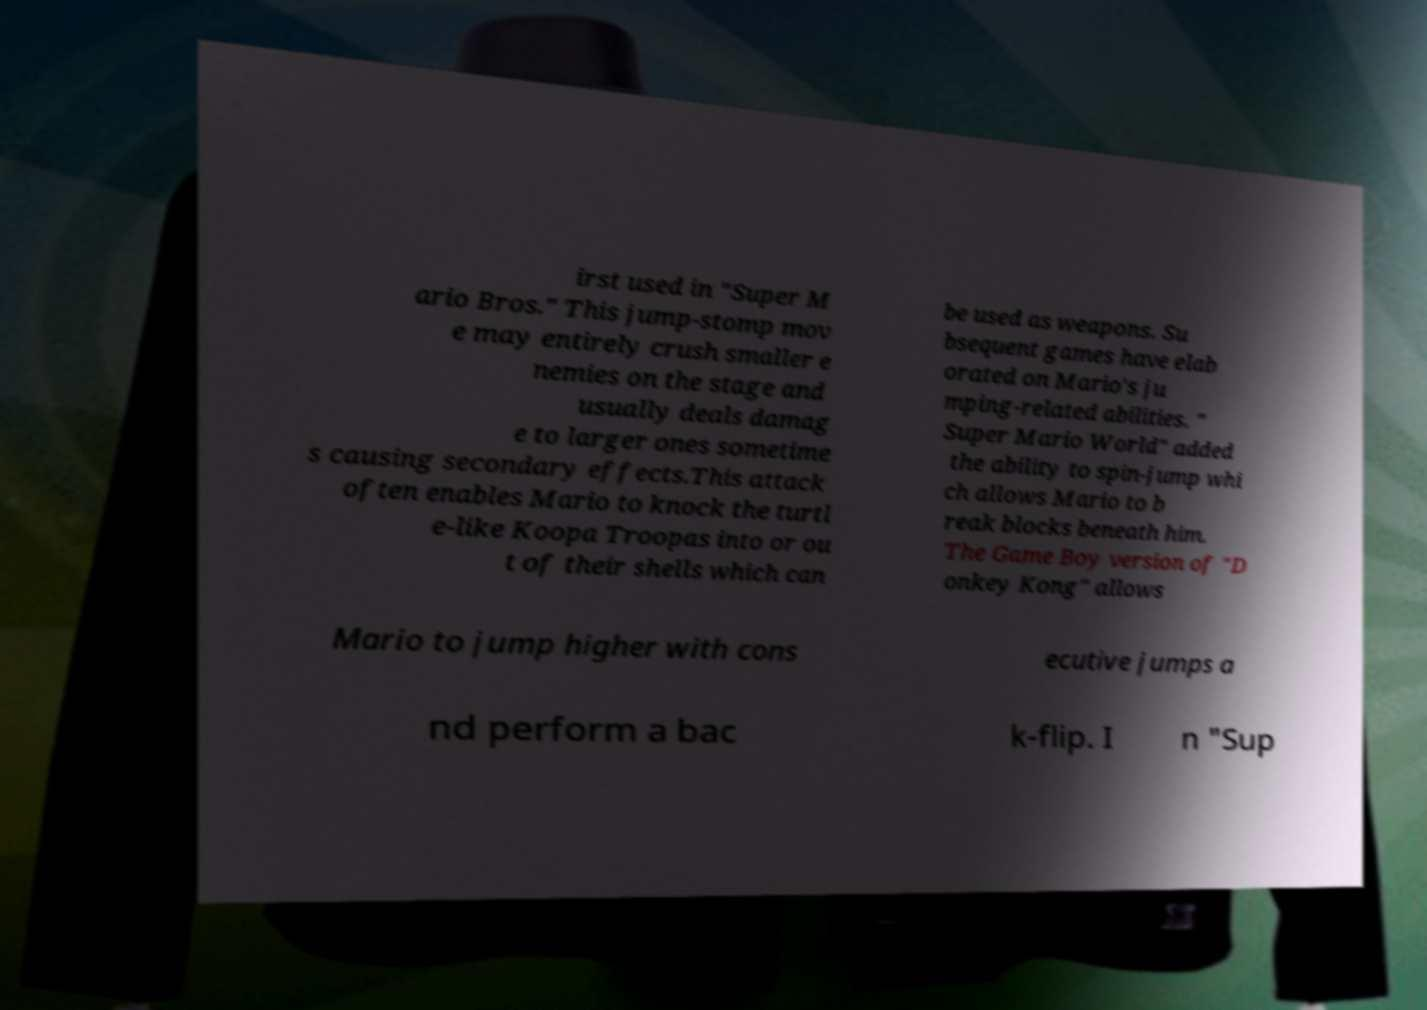Please read and relay the text visible in this image. What does it say? irst used in "Super M ario Bros." This jump-stomp mov e may entirely crush smaller e nemies on the stage and usually deals damag e to larger ones sometime s causing secondary effects.This attack often enables Mario to knock the turtl e-like Koopa Troopas into or ou t of their shells which can be used as weapons. Su bsequent games have elab orated on Mario's ju mping-related abilities. " Super Mario World" added the ability to spin-jump whi ch allows Mario to b reak blocks beneath him. The Game Boy version of "D onkey Kong" allows Mario to jump higher with cons ecutive jumps a nd perform a bac k-flip. I n "Sup 